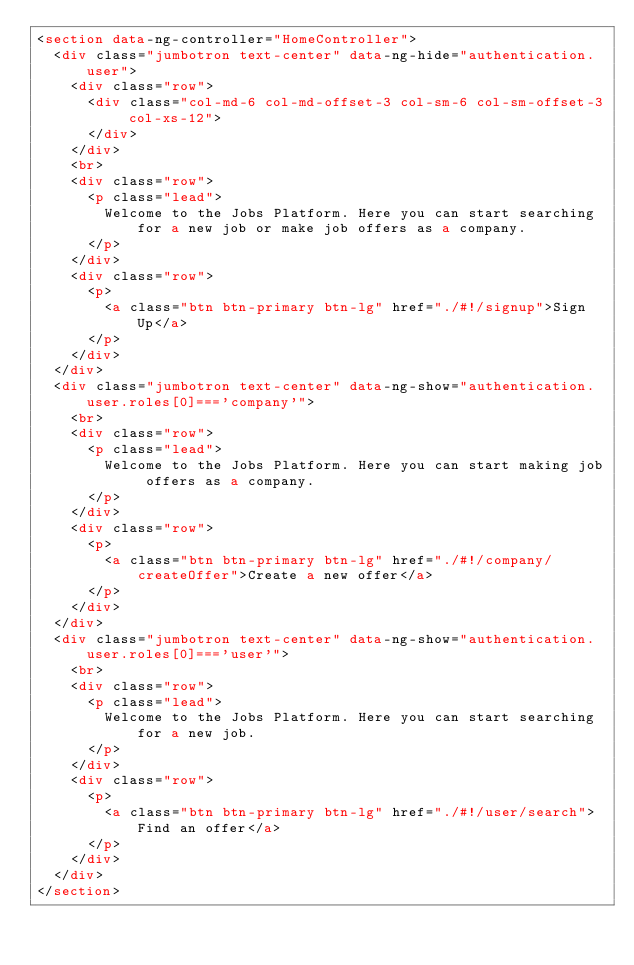Convert code to text. <code><loc_0><loc_0><loc_500><loc_500><_HTML_><section data-ng-controller="HomeController">
	<div class="jumbotron text-center" data-ng-hide="authentication.user">
		<div class="row">
			<div class="col-md-6 col-md-offset-3 col-sm-6 col-sm-offset-3 col-xs-12">
			</div>
		</div>
		<br>
		<div class="row">
			<p class="lead">
				Welcome to the Jobs Platform. Here you can start searching for a new job or make job offers as a company.
			</p>
		</div>
		<div class="row">
			<p>
				<a class="btn btn-primary btn-lg" href="./#!/signup">Sign Up</a>
			</p>
		</div>
	</div>
	<div class="jumbotron text-center" data-ng-show="authentication.user.roles[0]==='company'">
		<br>
		<div class="row">
			<p class="lead">
				Welcome to the Jobs Platform. Here you can start making job offers as a company.
			</p>
		</div>
		<div class="row">
			<p>
				<a class="btn btn-primary btn-lg" href="./#!/company/createOffer">Create a new offer</a>
			</p>
		</div>
	</div>
	<div class="jumbotron text-center" data-ng-show="authentication.user.roles[0]==='user'">
		<br>
		<div class="row">
			<p class="lead">
				Welcome to the Jobs Platform. Here you can start searching for a new job.
			</p>
		</div>
		<div class="row">
			<p>
				<a class="btn btn-primary btn-lg" href="./#!/user/search">Find an offer</a>
			</p>
		</div>
	</div>
</section>
</code> 